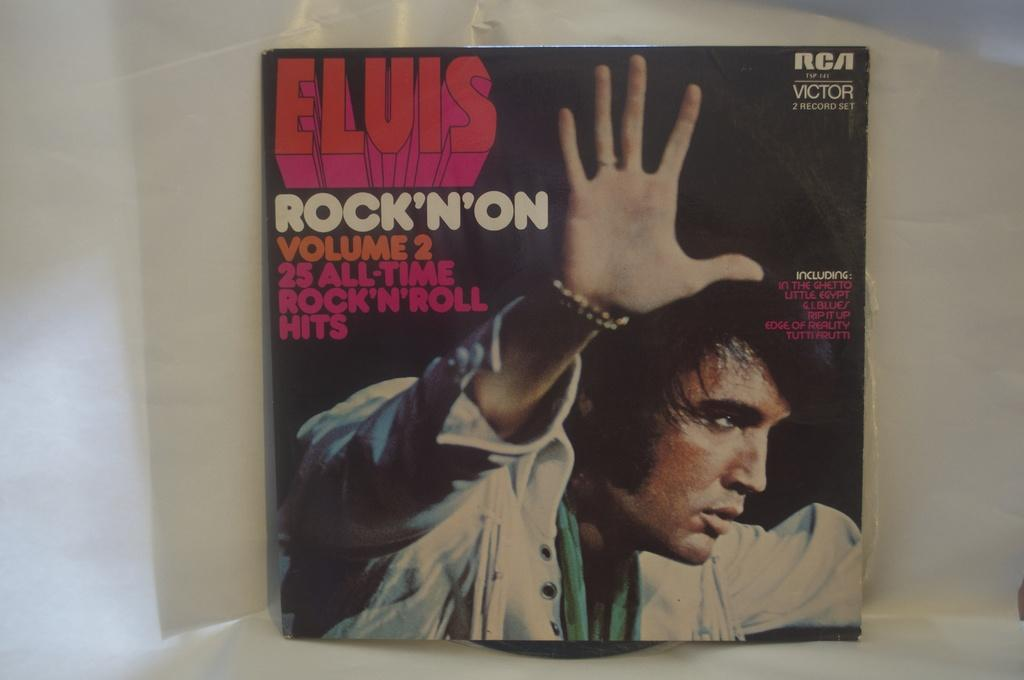<image>
Give a short and clear explanation of the subsequent image. Elvis Rock N On Volume 2 record of rock n roll. 